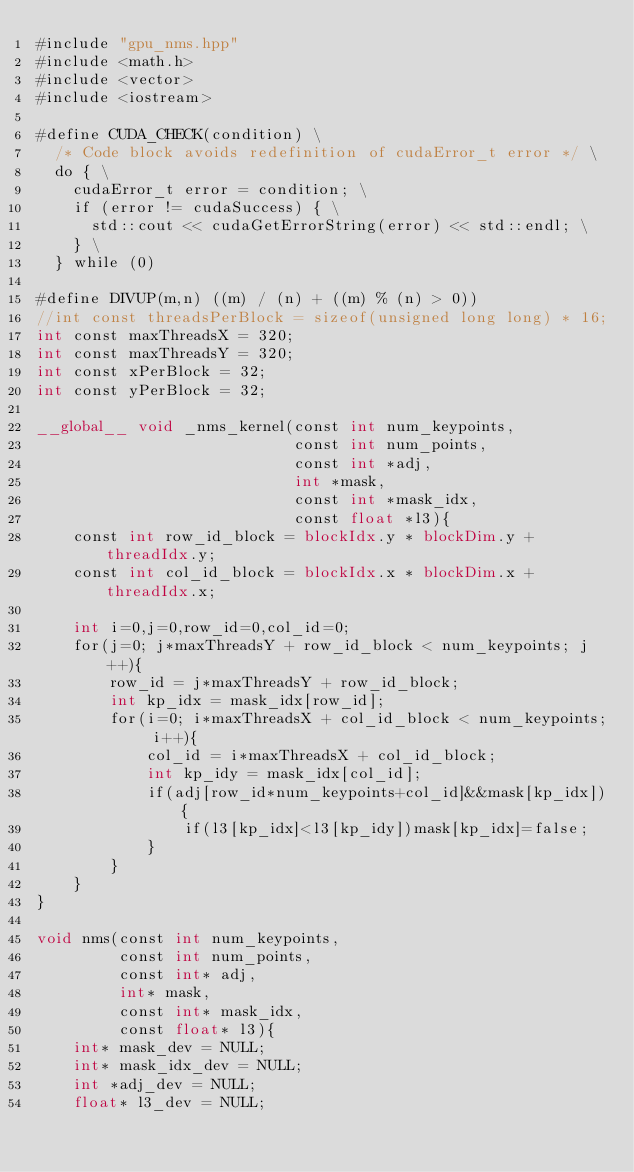<code> <loc_0><loc_0><loc_500><loc_500><_Cuda_>#include "gpu_nms.hpp"
#include <math.h>
#include <vector>
#include <iostream>

#define CUDA_CHECK(condition) \
  /* Code block avoids redefinition of cudaError_t error */ \
  do { \
    cudaError_t error = condition; \
    if (error != cudaSuccess) { \
      std::cout << cudaGetErrorString(error) << std::endl; \
    } \
  } while (0)

#define DIVUP(m,n) ((m) / (n) + ((m) % (n) > 0))
//int const threadsPerBlock = sizeof(unsigned long long) * 16;
int const maxThreadsX = 320;
int const maxThreadsY = 320;
int const xPerBlock = 32;
int const yPerBlock = 32;

__global__ void _nms_kernel(const int num_keypoints,
                            const int num_points, 
                            const int *adj,
                            int *mask,
                            const int *mask_idx,
                            const float *l3){
    const int row_id_block = blockIdx.y * blockDim.y + threadIdx.y;
    const int col_id_block = blockIdx.x * blockDim.x + threadIdx.x;
    
    int i=0,j=0,row_id=0,col_id=0;
    for(j=0; j*maxThreadsY + row_id_block < num_keypoints; j++){
        row_id = j*maxThreadsY + row_id_block;
        int kp_idx = mask_idx[row_id];
        for(i=0; i*maxThreadsX + col_id_block < num_keypoints; i++){
            col_id = i*maxThreadsX + col_id_block;
            int kp_idy = mask_idx[col_id];
            if(adj[row_id*num_keypoints+col_id]&&mask[kp_idx]){
                if(l3[kp_idx]<l3[kp_idy])mask[kp_idx]=false;
            }
        }
    }
}

void nms(const int num_keypoints,
         const int num_points,
         const int* adj,
         int* mask,
         const int* mask_idx,
         const float* l3){
    int* mask_dev = NULL;
    int* mask_idx_dev = NULL;
    int *adj_dev = NULL;
    float* l3_dev = NULL;
    </code> 